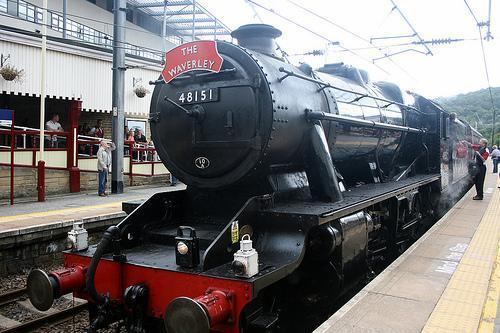How many people in picture?
Give a very brief answer. 5. 